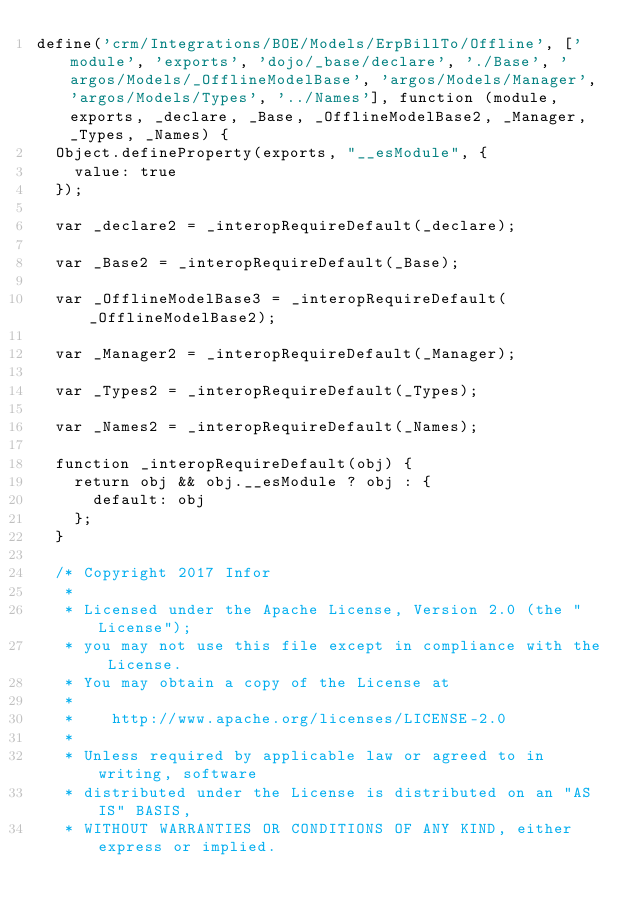<code> <loc_0><loc_0><loc_500><loc_500><_JavaScript_>define('crm/Integrations/BOE/Models/ErpBillTo/Offline', ['module', 'exports', 'dojo/_base/declare', './Base', 'argos/Models/_OfflineModelBase', 'argos/Models/Manager', 'argos/Models/Types', '../Names'], function (module, exports, _declare, _Base, _OfflineModelBase2, _Manager, _Types, _Names) {
  Object.defineProperty(exports, "__esModule", {
    value: true
  });

  var _declare2 = _interopRequireDefault(_declare);

  var _Base2 = _interopRequireDefault(_Base);

  var _OfflineModelBase3 = _interopRequireDefault(_OfflineModelBase2);

  var _Manager2 = _interopRequireDefault(_Manager);

  var _Types2 = _interopRequireDefault(_Types);

  var _Names2 = _interopRequireDefault(_Names);

  function _interopRequireDefault(obj) {
    return obj && obj.__esModule ? obj : {
      default: obj
    };
  }

  /* Copyright 2017 Infor
   *
   * Licensed under the Apache License, Version 2.0 (the "License");
   * you may not use this file except in compliance with the License.
   * You may obtain a copy of the License at
   *
   *    http://www.apache.org/licenses/LICENSE-2.0
   *
   * Unless required by applicable law or agreed to in writing, software
   * distributed under the License is distributed on an "AS IS" BASIS,
   * WITHOUT WARRANTIES OR CONDITIONS OF ANY KIND, either express or implied.</code> 